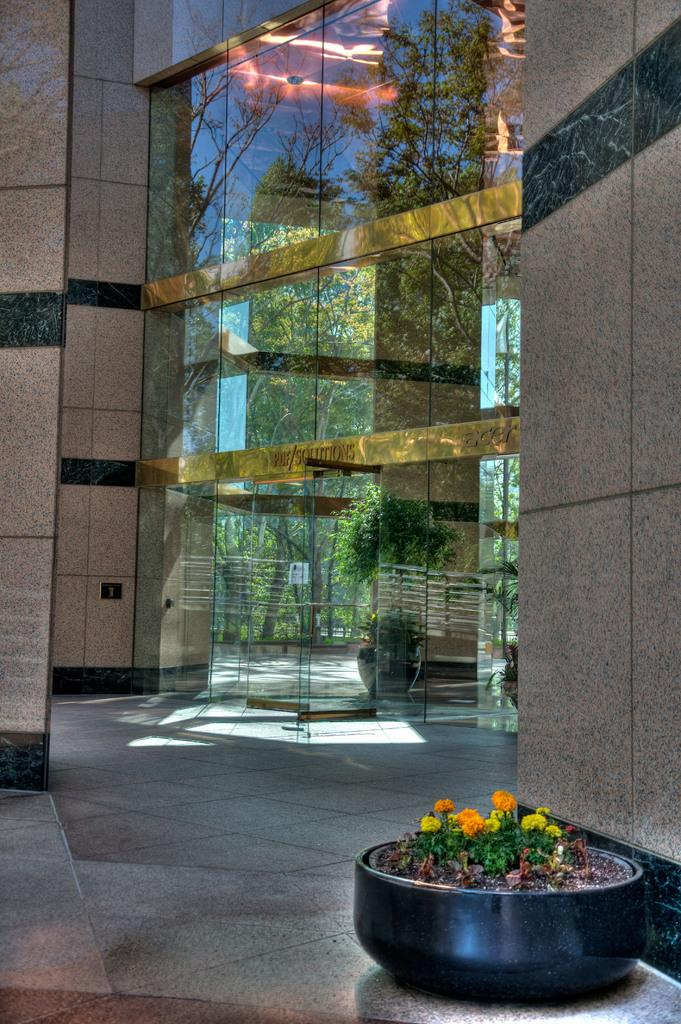What type of structure is visible in the image? There are walls in the image, which suggests a structure such as a house or building. What type of decorative elements can be seen in the image? There are house plants in the image, which add a natural touch to the space. What type of doors are present in the image? There are glass doors in the image, which allow for natural light to enter the space. What type of furniture is mentioned in the caption of the image? There is no caption present in the image, so it is not possible to determine what type of furniture might be mentioned. 